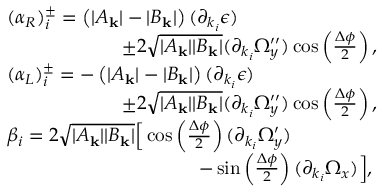Convert formula to latex. <formula><loc_0><loc_0><loc_500><loc_500>\begin{array} { r l } & { ( \alpha _ { R } ) _ { i } ^ { \pm } = \left ( | A _ { k } | - | B _ { k } | \right ) ( \partial _ { k _ { i } } \epsilon ) } \\ & { \quad \pm 2 \sqrt { | A _ { k } | | B _ { k } | } ( \partial _ { k _ { i } } \Omega _ { y } ^ { \prime \prime } ) \cos \left ( \frac { \Delta \phi } { 2 } \right ) , } \\ & { ( \alpha _ { L } ) _ { i } ^ { \pm } = - \left ( | A _ { k } | - | B _ { k } | \right ) ( \partial _ { k _ { i } } \epsilon ) } \\ & { \quad \pm 2 \sqrt { | A _ { k } | | B _ { k } | } ( \partial _ { k _ { i } } \Omega _ { y } ^ { \prime \prime } ) \cos \left ( \frac { \Delta \phi } { 2 } \right ) , } \\ & { \beta _ { i } = 2 \sqrt { | A _ { k } | | B _ { k } | } \left [ \cos \left ( \frac { \Delta \phi } { 2 } \right ) ( \partial _ { k _ { i } } \Omega _ { y } ^ { \prime } ) } \\ & { \quad - \sin \left ( \frac { \Delta \phi } { 2 } \right ) ( \partial _ { k _ { i } } \Omega _ { x } ) \right ] , } \end{array}</formula> 